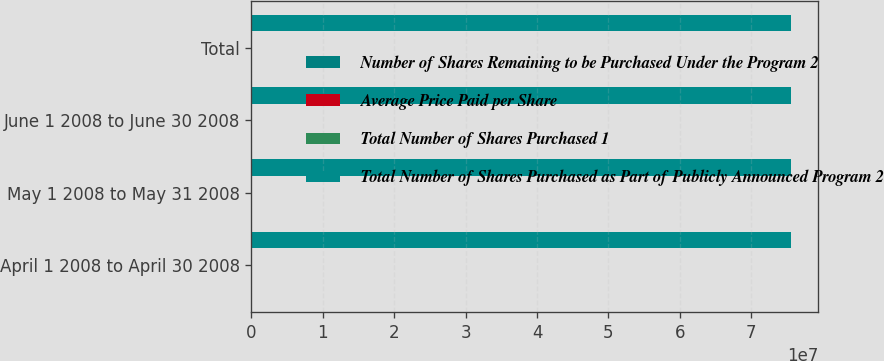Convert chart. <chart><loc_0><loc_0><loc_500><loc_500><stacked_bar_chart><ecel><fcel>April 1 2008 to April 30 2008<fcel>May 1 2008 to May 31 2008<fcel>June 1 2008 to June 30 2008<fcel>Total<nl><fcel>Number of Shares Remaining to be Purchased Under the Program 2<fcel>1799<fcel>9061<fcel>118<fcel>10978<nl><fcel>Average Price Paid per Share<fcel>47.13<fcel>43.99<fcel>41.8<fcel>44.48<nl><fcel>Total Number of Shares Purchased 1<fcel>307<fcel>154<fcel>118<fcel>579<nl><fcel>Total Number of Shares Purchased as Part of Publicly Announced Program 2<fcel>7.56306e+07<fcel>7.56304e+07<fcel>7.56303e+07<fcel>7.56303e+07<nl></chart> 